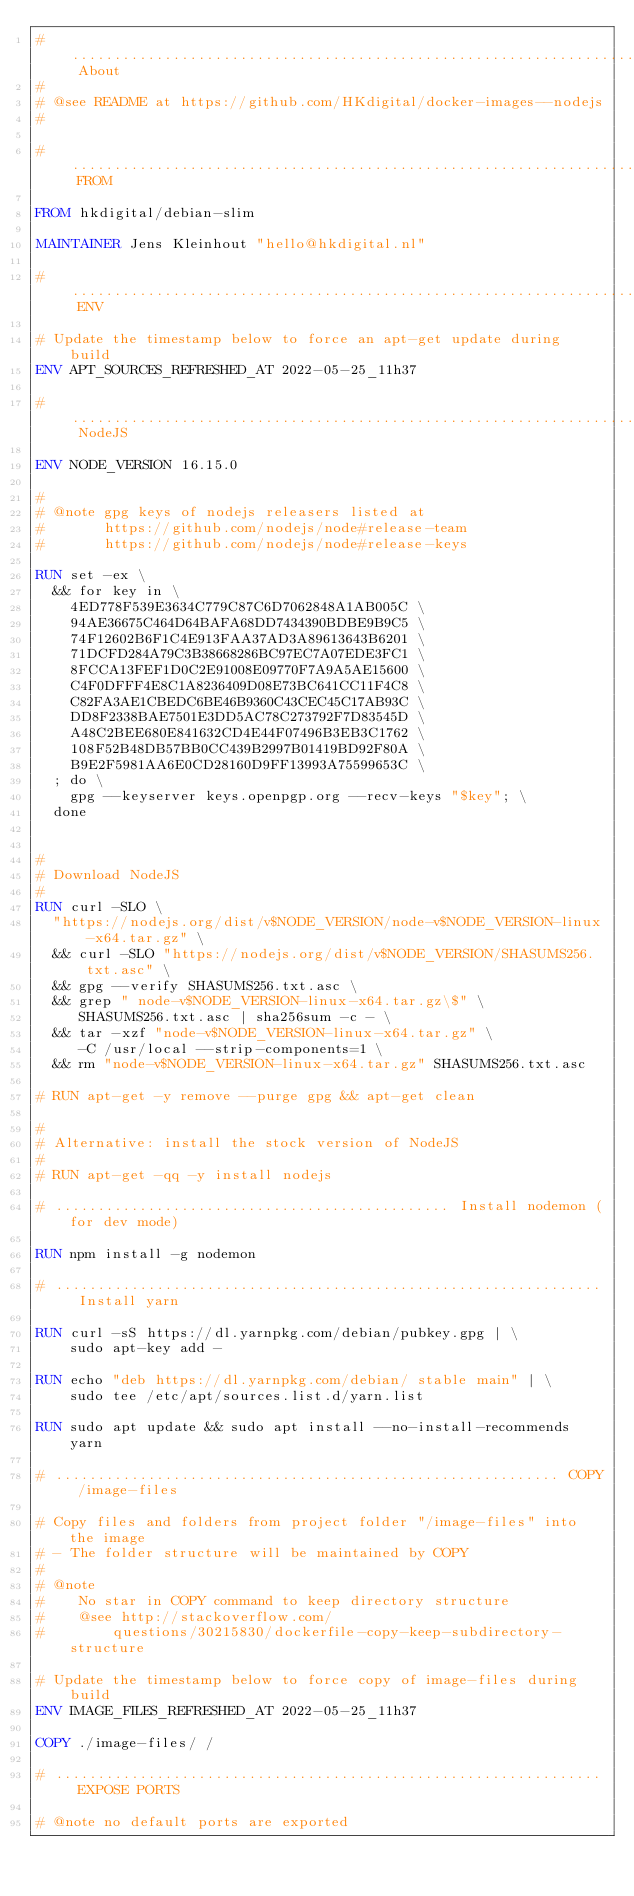Convert code to text. <code><loc_0><loc_0><loc_500><loc_500><_Dockerfile_># ........................................................................ About
#
# @see README at https://github.com/HKdigital/docker-images--nodejs
#

# ......................................................................... FROM

FROM hkdigital/debian-slim

MAINTAINER Jens Kleinhout "hello@hkdigital.nl"

# .......................................................................... ENV

# Update the timestamp below to force an apt-get update during build
ENV APT_SOURCES_REFRESHED_AT 2022-05-25_11h37

# ....................................................................... NodeJS

ENV NODE_VERSION 16.15.0

#
# @note gpg keys of nodejs releasers listed at
#       https://github.com/nodejs/node#release-team
#       https://github.com/nodejs/node#release-keys

RUN set -ex \
  && for key in \
    4ED778F539E3634C779C87C6D7062848A1AB005C \
    94AE36675C464D64BAFA68DD7434390BDBE9B9C5 \
    74F12602B6F1C4E913FAA37AD3A89613643B6201 \
    71DCFD284A79C3B38668286BC97EC7A07EDE3FC1 \
    8FCCA13FEF1D0C2E91008E09770F7A9A5AE15600 \
    C4F0DFFF4E8C1A8236409D08E73BC641CC11F4C8 \
    C82FA3AE1CBEDC6BE46B9360C43CEC45C17AB93C \
    DD8F2338BAE7501E3DD5AC78C273792F7D83545D \
    A48C2BEE680E841632CD4E44F07496B3EB3C1762 \
    108F52B48DB57BB0CC439B2997B01419BD92F80A \
    B9E2F5981AA6E0CD28160D9FF13993A75599653C \
  ; do \
    gpg --keyserver keys.openpgp.org --recv-keys "$key"; \
  done


#
# Download NodeJS
#
RUN curl -SLO \
  "https://nodejs.org/dist/v$NODE_VERSION/node-v$NODE_VERSION-linux-x64.tar.gz" \
  && curl -SLO "https://nodejs.org/dist/v$NODE_VERSION/SHASUMS256.txt.asc" \
  && gpg --verify SHASUMS256.txt.asc \
  && grep " node-v$NODE_VERSION-linux-x64.tar.gz\$" \
     SHASUMS256.txt.asc | sha256sum -c - \
  && tar -xzf "node-v$NODE_VERSION-linux-x64.tar.gz" \
     -C /usr/local --strip-components=1 \
  && rm "node-v$NODE_VERSION-linux-x64.tar.gz" SHASUMS256.txt.asc

# RUN apt-get -y remove --purge gpg && apt-get clean

#
# Alternative: install the stock version of NodeJS
#
# RUN apt-get -qq -y install nodejs

# ............................................... Install nodemon (for dev mode)

RUN npm install -g nodemon

# ................................................................. Install yarn

RUN curl -sS https://dl.yarnpkg.com/debian/pubkey.gpg | \
    sudo apt-key add -

RUN echo "deb https://dl.yarnpkg.com/debian/ stable main" | \
    sudo tee /etc/apt/sources.list.d/yarn.list

RUN sudo apt update && sudo apt install --no-install-recommends yarn

# ............................................................ COPY /image-files

# Copy files and folders from project folder "/image-files" into the image
# - The folder structure will be maintained by COPY
#
# @note
#    No star in COPY command to keep directory structure
#    @see http://stackoverflow.com/
#        questions/30215830/dockerfile-copy-keep-subdirectory-structure

# Update the timestamp below to force copy of image-files during build
ENV IMAGE_FILES_REFRESHED_AT 2022-05-25_11h37

COPY ./image-files/ /

# ................................................................. EXPOSE PORTS

# @note no default ports are exported
</code> 